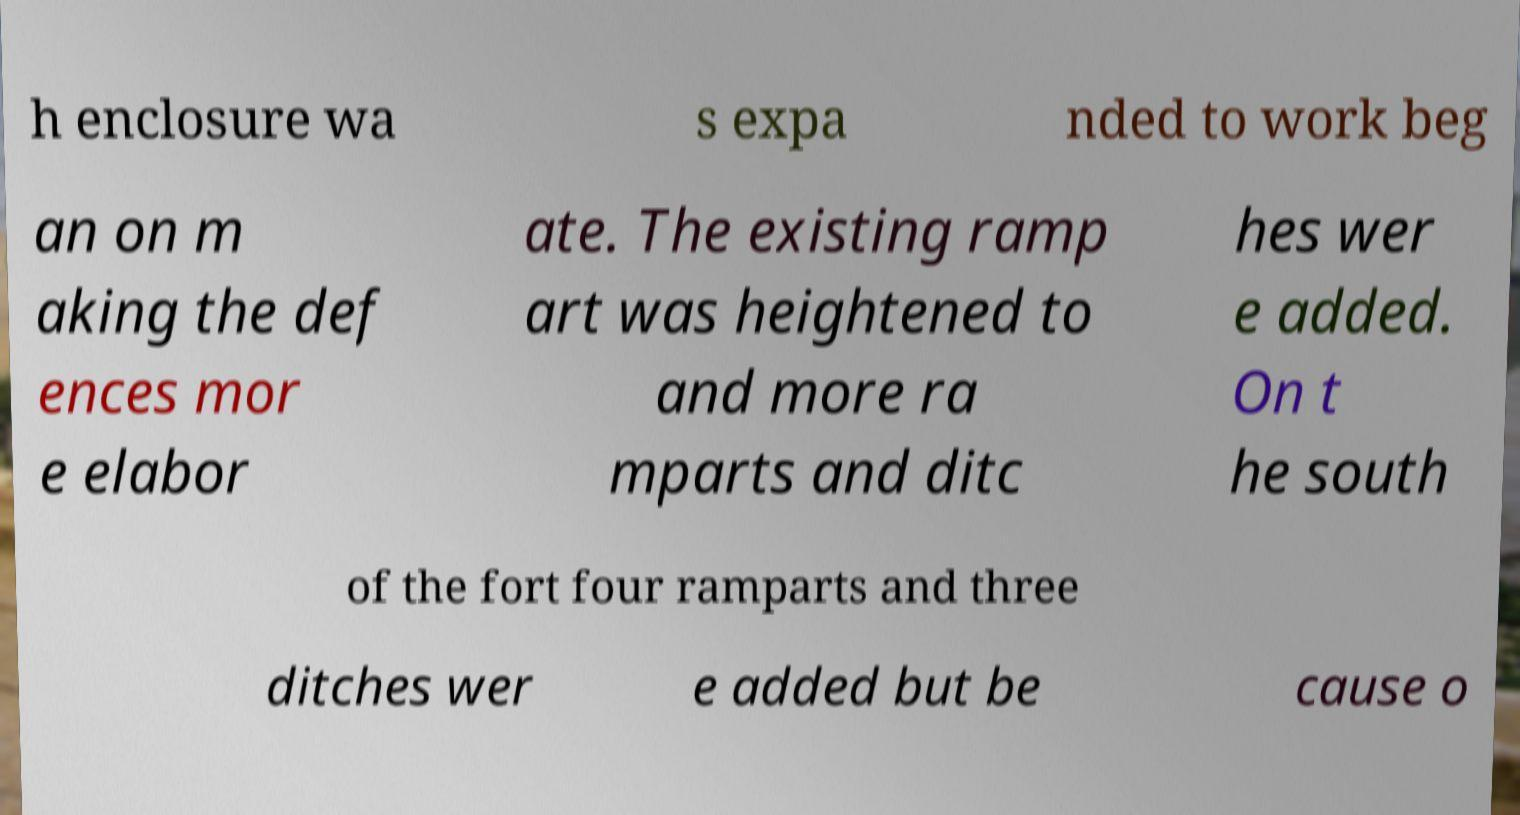Please read and relay the text visible in this image. What does it say? h enclosure wa s expa nded to work beg an on m aking the def ences mor e elabor ate. The existing ramp art was heightened to and more ra mparts and ditc hes wer e added. On t he south of the fort four ramparts and three ditches wer e added but be cause o 